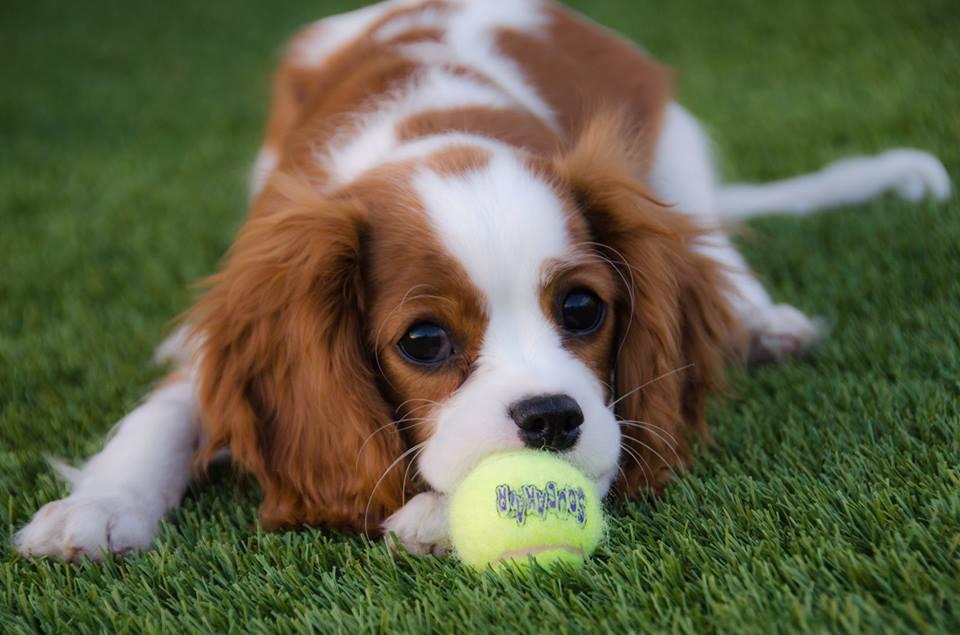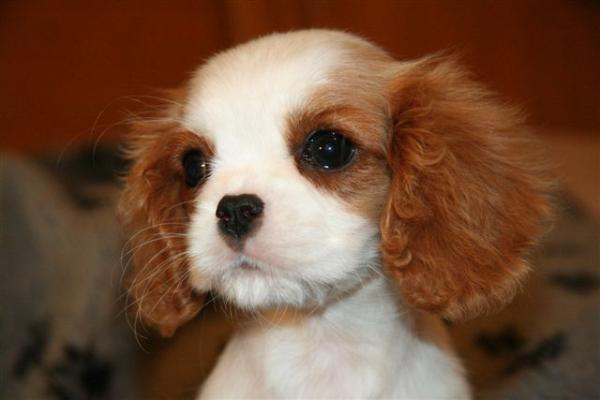The first image is the image on the left, the second image is the image on the right. Evaluate the accuracy of this statement regarding the images: "The dog in the image on the left is outside.". Is it true? Answer yes or no. Yes. 